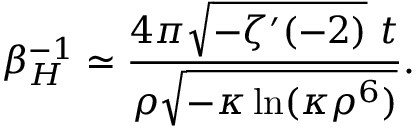<formula> <loc_0><loc_0><loc_500><loc_500>\beta _ { H } ^ { - 1 } \simeq \frac { 4 \pi \sqrt { - \zeta ^ { \prime } ( - 2 ) } \ t } { \rho \sqrt { - \kappa \ln ( \kappa \rho ^ { 6 } ) } } .</formula> 